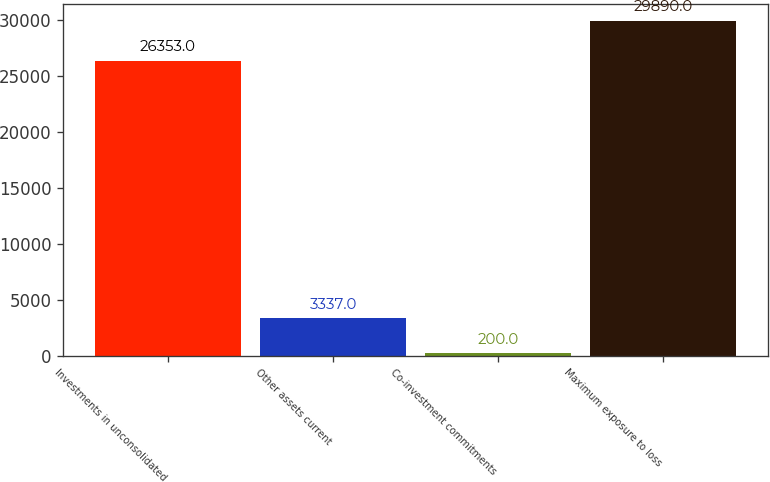Convert chart to OTSL. <chart><loc_0><loc_0><loc_500><loc_500><bar_chart><fcel>Investments in unconsolidated<fcel>Other assets current<fcel>Co-investment commitments<fcel>Maximum exposure to loss<nl><fcel>26353<fcel>3337<fcel>200<fcel>29890<nl></chart> 